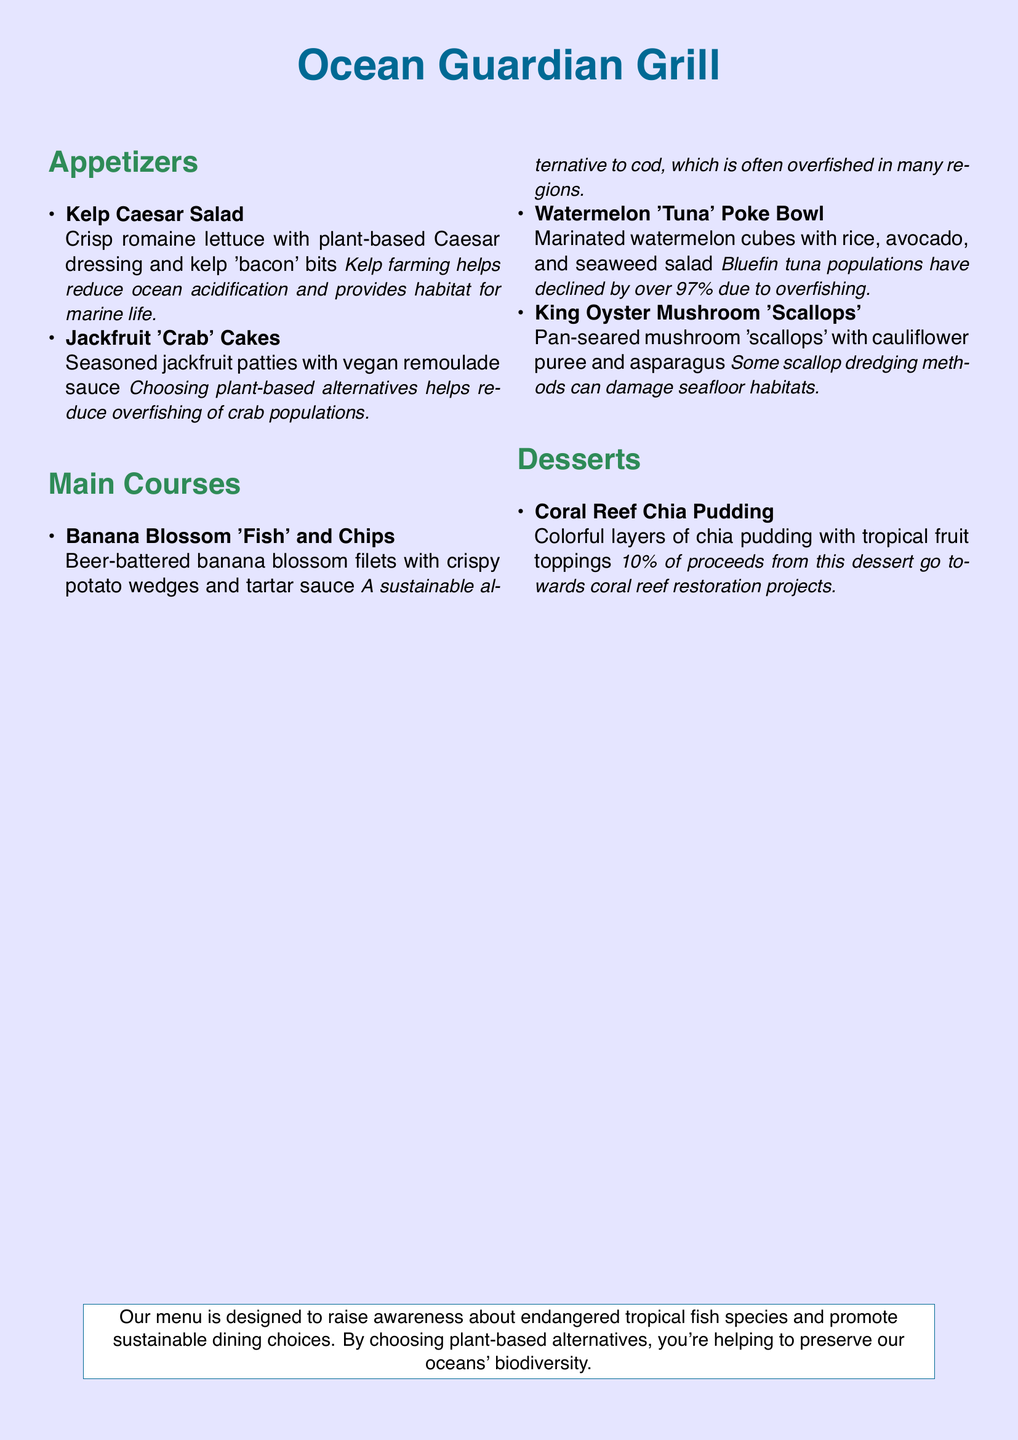what is the name of the restaurant? The name of the restaurant is prominently displayed at the top of the document.
Answer: Ocean Guardian Grill how many appetizers are listed on the menu? The document lists three items under the appetizers section.
Answer: 2 what is the main ingredient in the Banana Blossom 'Fish' and Chips? The dish features beer-battered banana blossom filets as its main ingredient.
Answer: banana blossom what percentage of proceeds from the Coral Reef Chia Pudding go to restoration projects? The document explicitly states the percentage related to the proceeds from this dessert.
Answer: 10% what is the alternative name for Jackfruit 'Crab' Cakes? The item is described using its alternative name referring to jackfruit.
Answer: crab which ingredient in the Watermelon 'Tuna' Poke Bowl is marinated? The main ingredient in this dish is highlighted as being marinated in the description.
Answer: watermelon what type of mushrooms are used in the King Oyster Mushroom 'Scallops'? The name of the mushroom used is mentioned in the dish's title.
Answer: King Oyster Mushroom what theme does the menu promote? A thematic focus is explained at the end of the document.
Answer: ocean preservation 